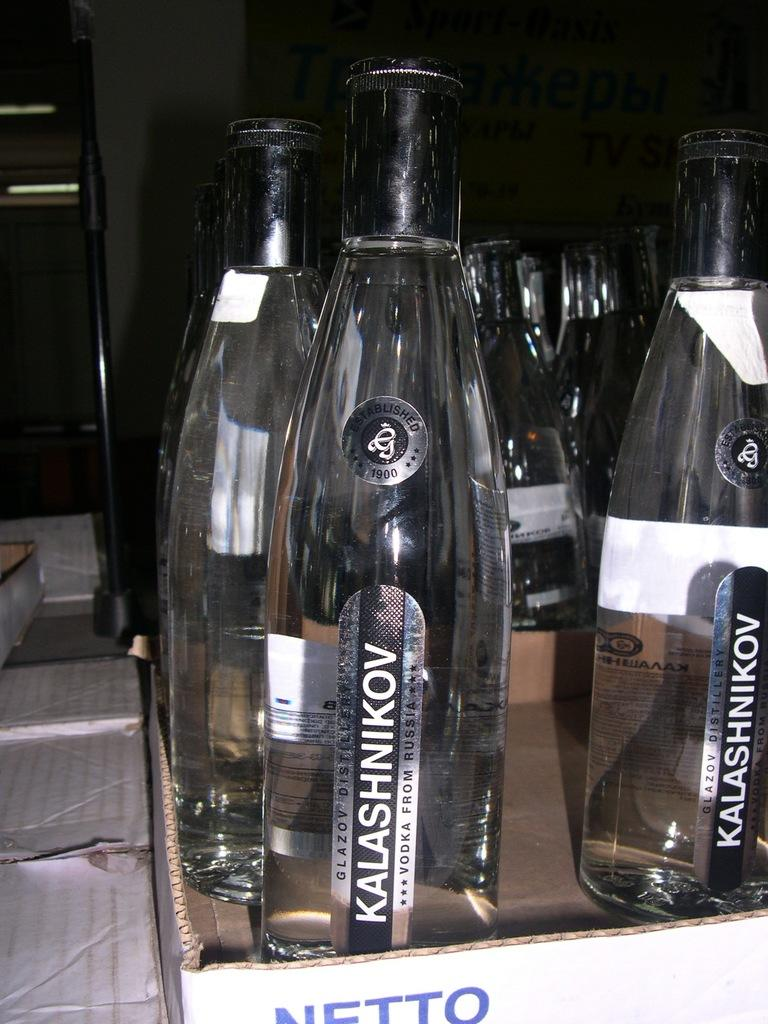<image>
Provide a brief description of the given image. A few bottles of vodka from Kalashnikov from Russia. 